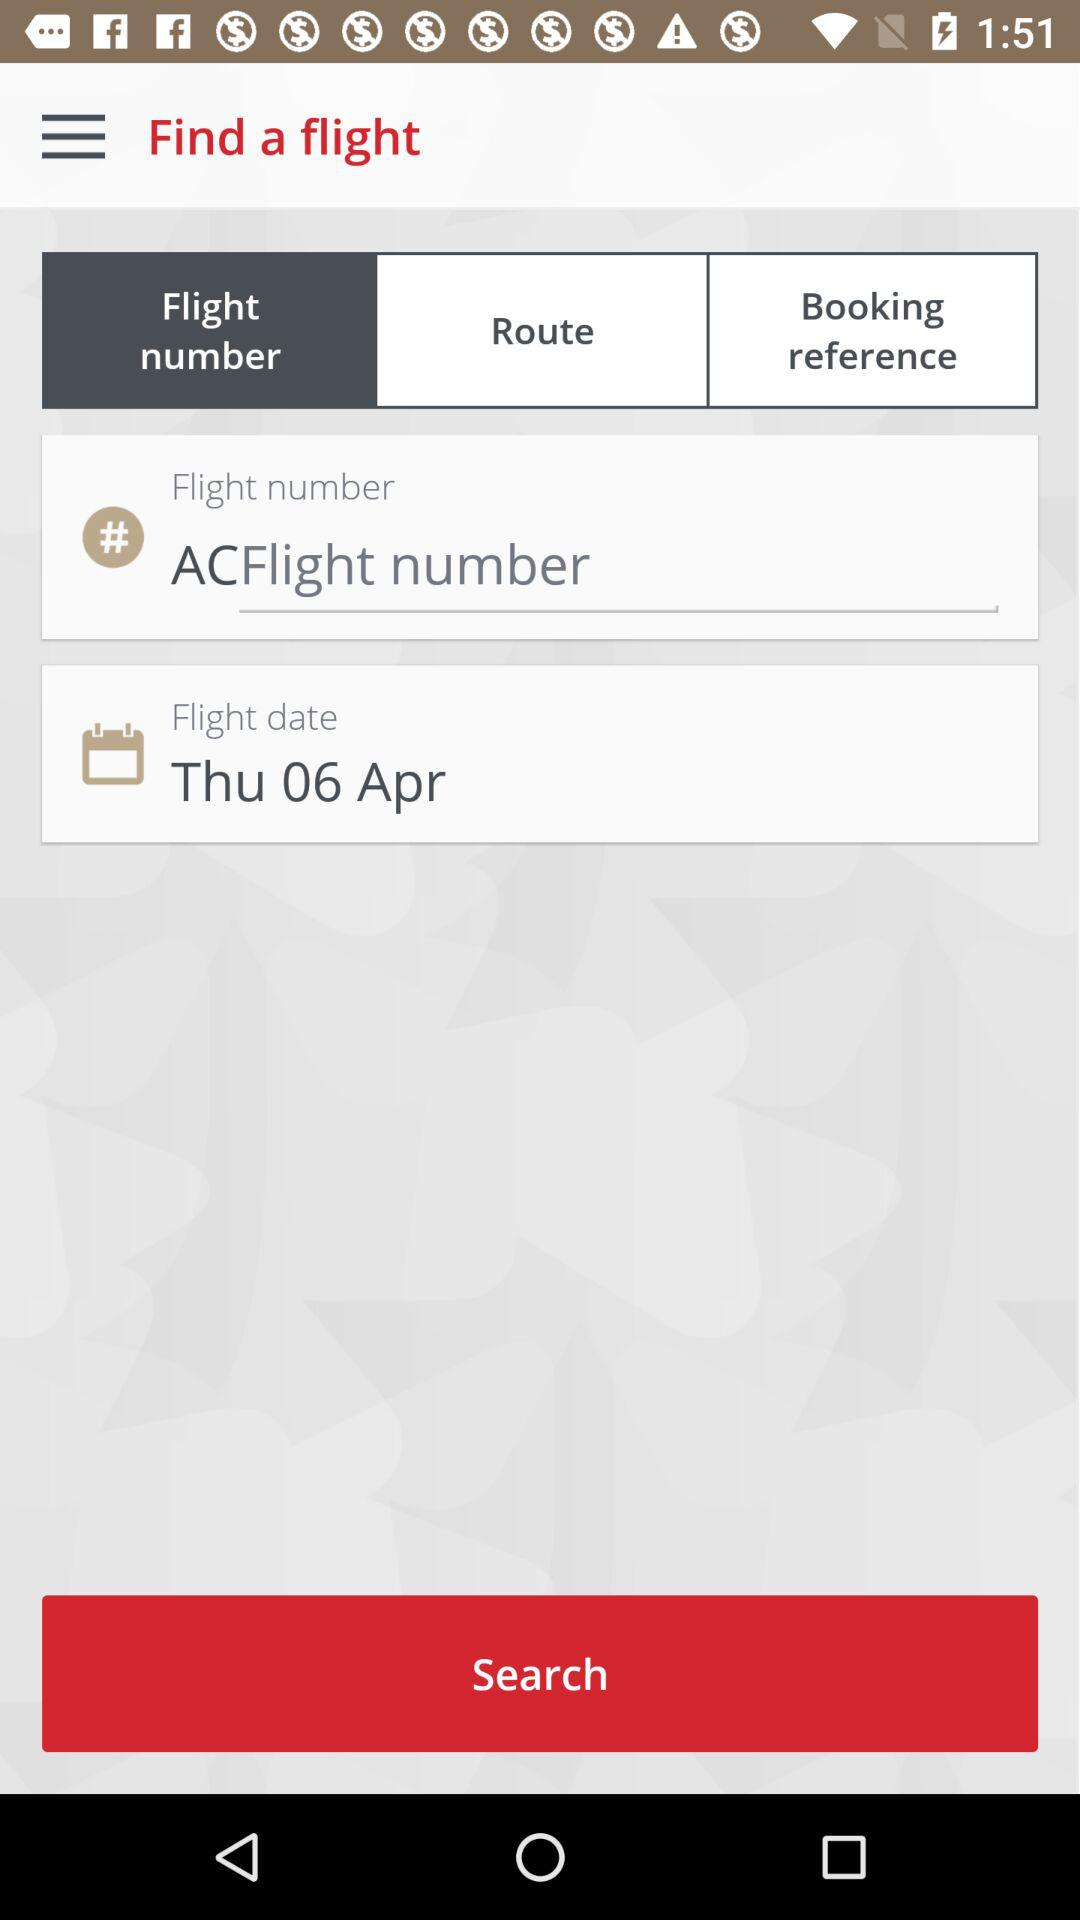What additional features does this flight search interface offer based on the image? In addition to the standard fields for entering flight numbers, dates, and booking references, the interface likely includes features for filtering by airline, fare class, or number of passengers. It may also have tools for comparing prices, viewing seat availability, and even saving searches or setting up alerts for fare changes. 